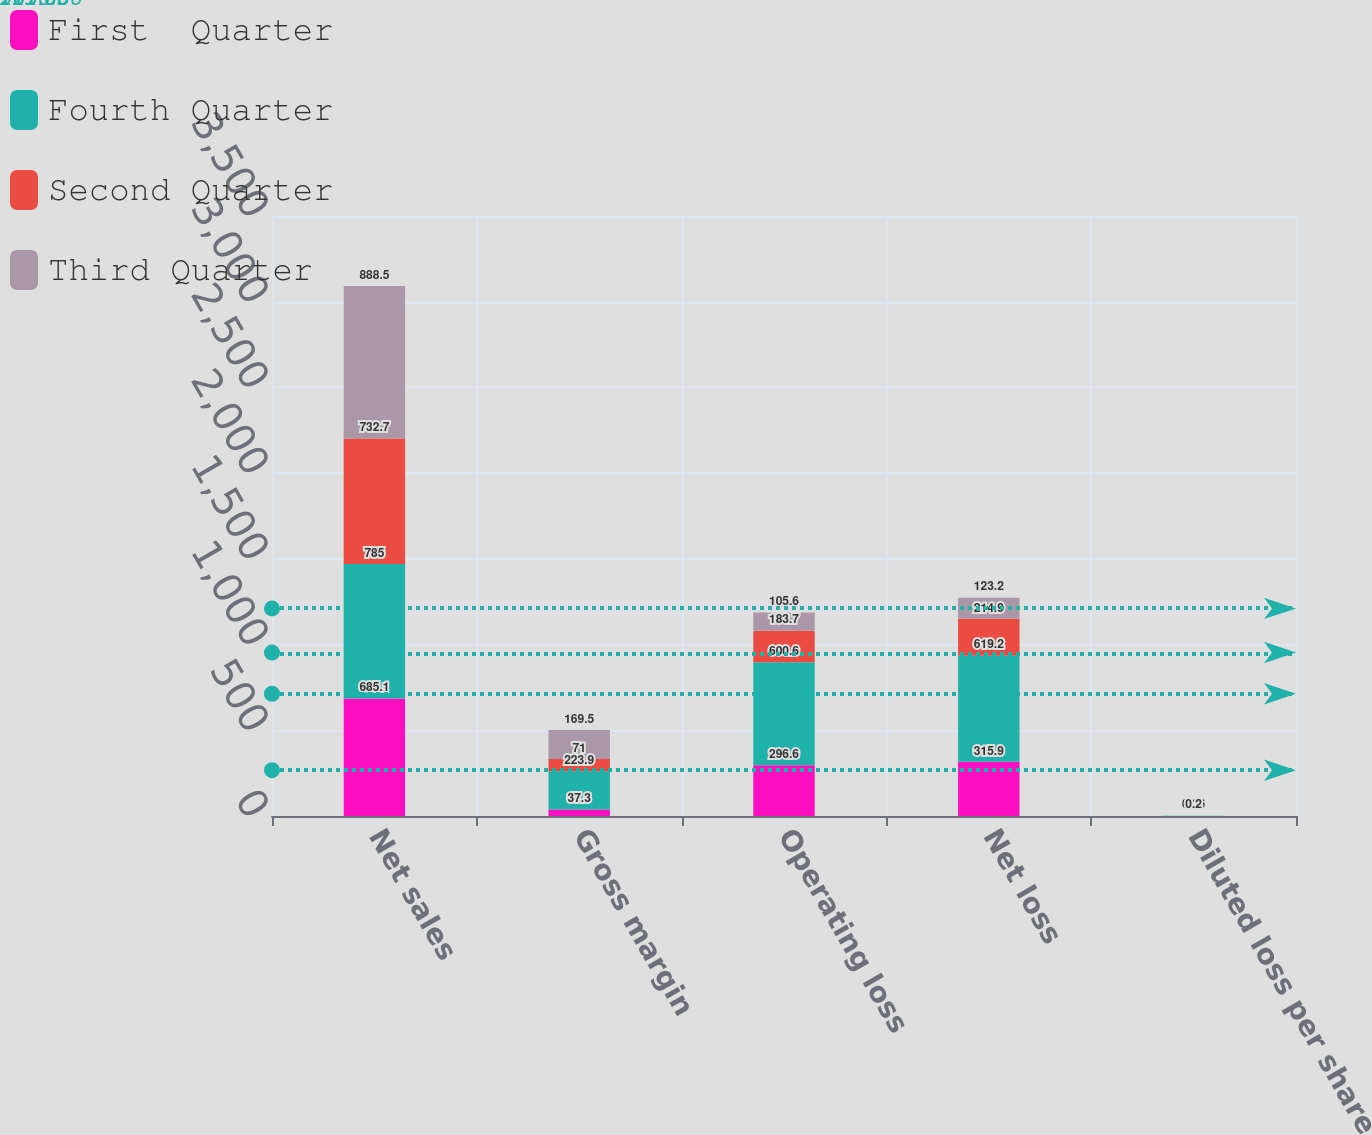<chart> <loc_0><loc_0><loc_500><loc_500><stacked_bar_chart><ecel><fcel>Net sales<fcel>Gross margin<fcel>Operating loss<fcel>Net loss<fcel>Diluted loss per share<nl><fcel>First  Quarter<fcel>685.1<fcel>37.3<fcel>296.6<fcel>315.9<fcel>0.52<nl><fcel>Fourth Quarter<fcel>785<fcel>223.9<fcel>600.6<fcel>619.2<fcel>1.02<nl><fcel>Second Quarter<fcel>732.7<fcel>71<fcel>183.7<fcel>214.9<fcel>0.36<nl><fcel>Third Quarter<fcel>888.5<fcel>169.5<fcel>105.6<fcel>123.2<fcel>0.2<nl></chart> 